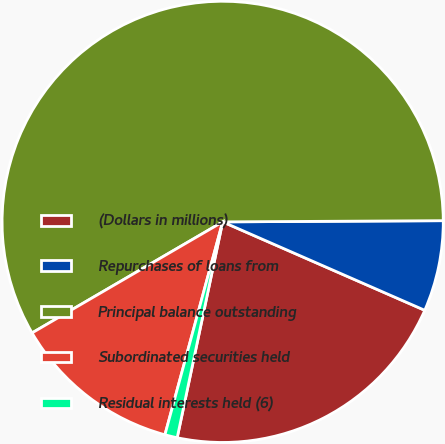Convert chart. <chart><loc_0><loc_0><loc_500><loc_500><pie_chart><fcel>(Dollars in millions)<fcel>Repurchases of loans from<fcel>Principal balance outstanding<fcel>Subordinated securities held<fcel>Residual interests held (6)<nl><fcel>21.74%<fcel>6.65%<fcel>58.31%<fcel>12.39%<fcel>0.91%<nl></chart> 